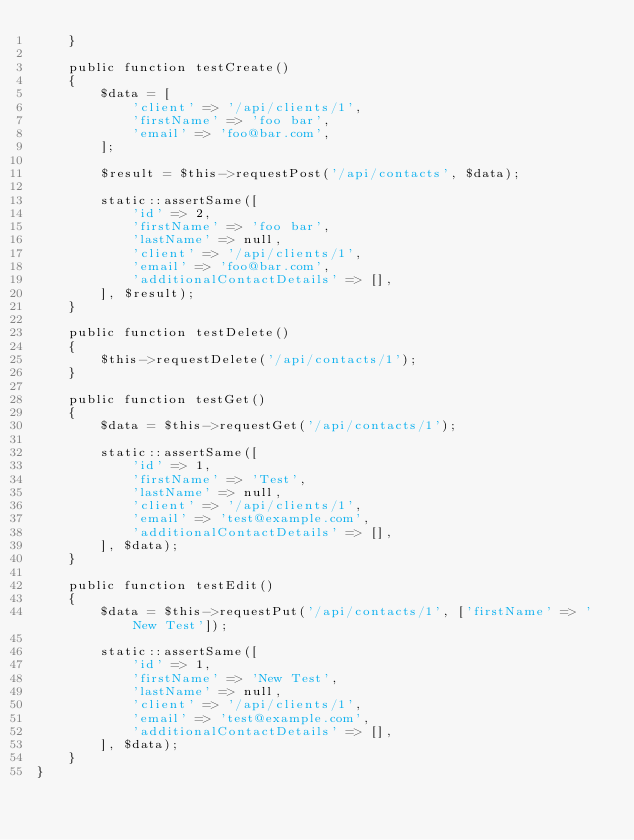Convert code to text. <code><loc_0><loc_0><loc_500><loc_500><_PHP_>    }

    public function testCreate()
    {
        $data = [
            'client' => '/api/clients/1',
            'firstName' => 'foo bar',
            'email' => 'foo@bar.com',
        ];

        $result = $this->requestPost('/api/contacts', $data);

        static::assertSame([
            'id' => 2,
            'firstName' => 'foo bar',
            'lastName' => null,
            'client' => '/api/clients/1',
            'email' => 'foo@bar.com',
            'additionalContactDetails' => [],
        ], $result);
    }

    public function testDelete()
    {
        $this->requestDelete('/api/contacts/1');
    }

    public function testGet()
    {
        $data = $this->requestGet('/api/contacts/1');

        static::assertSame([
            'id' => 1,
            'firstName' => 'Test',
            'lastName' => null,
            'client' => '/api/clients/1',
            'email' => 'test@example.com',
            'additionalContactDetails' => [],
        ], $data);
    }

    public function testEdit()
    {
        $data = $this->requestPut('/api/contacts/1', ['firstName' => 'New Test']);

        static::assertSame([
            'id' => 1,
            'firstName' => 'New Test',
            'lastName' => null,
            'client' => '/api/clients/1',
            'email' => 'test@example.com',
            'additionalContactDetails' => [],
        ], $data);
    }
}
</code> 